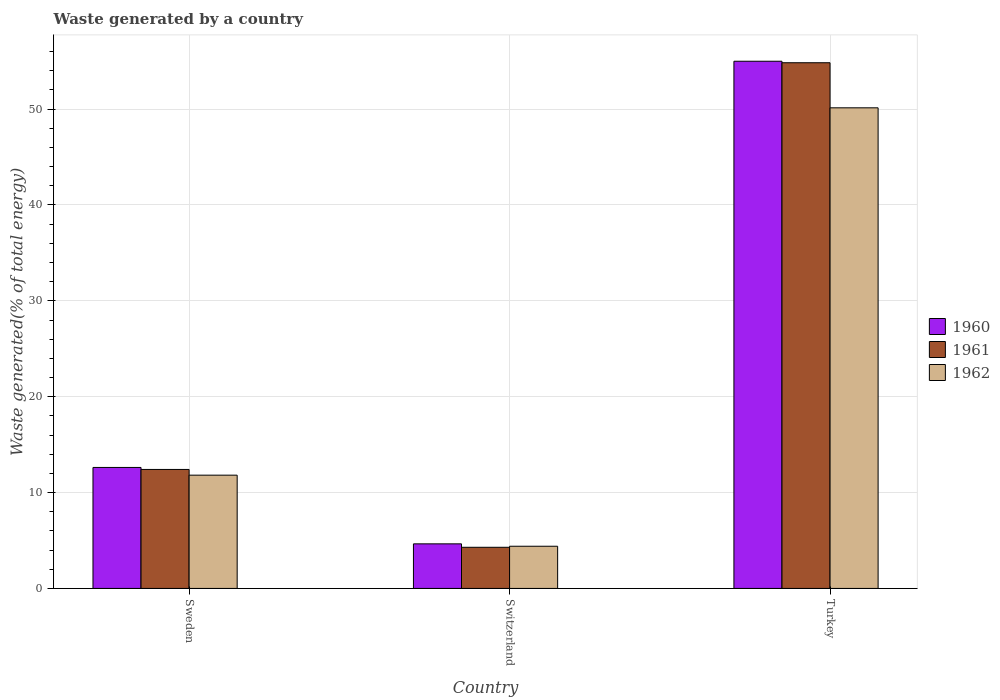How many different coloured bars are there?
Your response must be concise. 3. Are the number of bars per tick equal to the number of legend labels?
Provide a succinct answer. Yes. What is the label of the 2nd group of bars from the left?
Your response must be concise. Switzerland. What is the total waste generated in 1961 in Turkey?
Give a very brief answer. 54.84. Across all countries, what is the maximum total waste generated in 1961?
Give a very brief answer. 54.84. Across all countries, what is the minimum total waste generated in 1962?
Make the answer very short. 4.4. In which country was the total waste generated in 1960 maximum?
Keep it short and to the point. Turkey. In which country was the total waste generated in 1962 minimum?
Make the answer very short. Switzerland. What is the total total waste generated in 1961 in the graph?
Make the answer very short. 71.54. What is the difference between the total waste generated in 1962 in Sweden and that in Turkey?
Offer a very short reply. -38.32. What is the difference between the total waste generated in 1962 in Switzerland and the total waste generated in 1960 in Sweden?
Provide a succinct answer. -8.22. What is the average total waste generated in 1961 per country?
Your response must be concise. 23.85. What is the difference between the total waste generated of/in 1962 and total waste generated of/in 1960 in Sweden?
Offer a very short reply. -0.81. What is the ratio of the total waste generated in 1961 in Switzerland to that in Turkey?
Ensure brevity in your answer.  0.08. Is the total waste generated in 1960 in Sweden less than that in Turkey?
Your answer should be compact. Yes. What is the difference between the highest and the second highest total waste generated in 1962?
Your answer should be compact. 38.32. What is the difference between the highest and the lowest total waste generated in 1961?
Make the answer very short. 50.55. In how many countries, is the total waste generated in 1960 greater than the average total waste generated in 1960 taken over all countries?
Provide a succinct answer. 1. What does the 3rd bar from the left in Turkey represents?
Offer a terse response. 1962. Is it the case that in every country, the sum of the total waste generated in 1961 and total waste generated in 1962 is greater than the total waste generated in 1960?
Your answer should be compact. Yes. Where does the legend appear in the graph?
Offer a terse response. Center right. How many legend labels are there?
Make the answer very short. 3. How are the legend labels stacked?
Offer a very short reply. Vertical. What is the title of the graph?
Ensure brevity in your answer.  Waste generated by a country. Does "2007" appear as one of the legend labels in the graph?
Provide a succinct answer. No. What is the label or title of the X-axis?
Your answer should be very brief. Country. What is the label or title of the Y-axis?
Keep it short and to the point. Waste generated(% of total energy). What is the Waste generated(% of total energy) of 1960 in Sweden?
Offer a very short reply. 12.62. What is the Waste generated(% of total energy) in 1961 in Sweden?
Your answer should be very brief. 12.41. What is the Waste generated(% of total energy) in 1962 in Sweden?
Offer a very short reply. 11.82. What is the Waste generated(% of total energy) in 1960 in Switzerland?
Provide a short and direct response. 4.65. What is the Waste generated(% of total energy) in 1961 in Switzerland?
Give a very brief answer. 4.29. What is the Waste generated(% of total energy) in 1962 in Switzerland?
Offer a very short reply. 4.4. What is the Waste generated(% of total energy) in 1960 in Turkey?
Offer a terse response. 54.99. What is the Waste generated(% of total energy) in 1961 in Turkey?
Offer a terse response. 54.84. What is the Waste generated(% of total energy) of 1962 in Turkey?
Provide a succinct answer. 50.13. Across all countries, what is the maximum Waste generated(% of total energy) of 1960?
Make the answer very short. 54.99. Across all countries, what is the maximum Waste generated(% of total energy) in 1961?
Make the answer very short. 54.84. Across all countries, what is the maximum Waste generated(% of total energy) in 1962?
Give a very brief answer. 50.13. Across all countries, what is the minimum Waste generated(% of total energy) of 1960?
Keep it short and to the point. 4.65. Across all countries, what is the minimum Waste generated(% of total energy) of 1961?
Make the answer very short. 4.29. Across all countries, what is the minimum Waste generated(% of total energy) of 1962?
Make the answer very short. 4.4. What is the total Waste generated(% of total energy) of 1960 in the graph?
Offer a very short reply. 72.27. What is the total Waste generated(% of total energy) in 1961 in the graph?
Offer a very short reply. 71.54. What is the total Waste generated(% of total energy) in 1962 in the graph?
Provide a succinct answer. 66.35. What is the difference between the Waste generated(% of total energy) in 1960 in Sweden and that in Switzerland?
Offer a very short reply. 7.97. What is the difference between the Waste generated(% of total energy) in 1961 in Sweden and that in Switzerland?
Make the answer very short. 8.12. What is the difference between the Waste generated(% of total energy) of 1962 in Sweden and that in Switzerland?
Provide a succinct answer. 7.41. What is the difference between the Waste generated(% of total energy) in 1960 in Sweden and that in Turkey?
Your answer should be compact. -42.37. What is the difference between the Waste generated(% of total energy) in 1961 in Sweden and that in Turkey?
Make the answer very short. -42.43. What is the difference between the Waste generated(% of total energy) in 1962 in Sweden and that in Turkey?
Your answer should be very brief. -38.32. What is the difference between the Waste generated(% of total energy) in 1960 in Switzerland and that in Turkey?
Make the answer very short. -50.34. What is the difference between the Waste generated(% of total energy) of 1961 in Switzerland and that in Turkey?
Keep it short and to the point. -50.55. What is the difference between the Waste generated(% of total energy) of 1962 in Switzerland and that in Turkey?
Provide a succinct answer. -45.73. What is the difference between the Waste generated(% of total energy) of 1960 in Sweden and the Waste generated(% of total energy) of 1961 in Switzerland?
Keep it short and to the point. 8.33. What is the difference between the Waste generated(% of total energy) of 1960 in Sweden and the Waste generated(% of total energy) of 1962 in Switzerland?
Your answer should be compact. 8.22. What is the difference between the Waste generated(% of total energy) in 1961 in Sweden and the Waste generated(% of total energy) in 1962 in Switzerland?
Your answer should be compact. 8.01. What is the difference between the Waste generated(% of total energy) of 1960 in Sweden and the Waste generated(% of total energy) of 1961 in Turkey?
Your response must be concise. -42.22. What is the difference between the Waste generated(% of total energy) of 1960 in Sweden and the Waste generated(% of total energy) of 1962 in Turkey?
Your answer should be very brief. -37.51. What is the difference between the Waste generated(% of total energy) of 1961 in Sweden and the Waste generated(% of total energy) of 1962 in Turkey?
Your answer should be very brief. -37.72. What is the difference between the Waste generated(% of total energy) of 1960 in Switzerland and the Waste generated(% of total energy) of 1961 in Turkey?
Provide a short and direct response. -50.19. What is the difference between the Waste generated(% of total energy) of 1960 in Switzerland and the Waste generated(% of total energy) of 1962 in Turkey?
Keep it short and to the point. -45.48. What is the difference between the Waste generated(% of total energy) in 1961 in Switzerland and the Waste generated(% of total energy) in 1962 in Turkey?
Your answer should be very brief. -45.84. What is the average Waste generated(% of total energy) in 1960 per country?
Offer a very short reply. 24.09. What is the average Waste generated(% of total energy) of 1961 per country?
Your answer should be very brief. 23.85. What is the average Waste generated(% of total energy) in 1962 per country?
Ensure brevity in your answer.  22.12. What is the difference between the Waste generated(% of total energy) in 1960 and Waste generated(% of total energy) in 1961 in Sweden?
Provide a succinct answer. 0.21. What is the difference between the Waste generated(% of total energy) in 1960 and Waste generated(% of total energy) in 1962 in Sweden?
Provide a short and direct response. 0.81. What is the difference between the Waste generated(% of total energy) of 1961 and Waste generated(% of total energy) of 1962 in Sweden?
Ensure brevity in your answer.  0.6. What is the difference between the Waste generated(% of total energy) of 1960 and Waste generated(% of total energy) of 1961 in Switzerland?
Your response must be concise. 0.36. What is the difference between the Waste generated(% of total energy) in 1960 and Waste generated(% of total energy) in 1962 in Switzerland?
Provide a succinct answer. 0.25. What is the difference between the Waste generated(% of total energy) in 1961 and Waste generated(% of total energy) in 1962 in Switzerland?
Provide a succinct answer. -0.11. What is the difference between the Waste generated(% of total energy) of 1960 and Waste generated(% of total energy) of 1961 in Turkey?
Offer a very short reply. 0.16. What is the difference between the Waste generated(% of total energy) of 1960 and Waste generated(% of total energy) of 1962 in Turkey?
Give a very brief answer. 4.86. What is the difference between the Waste generated(% of total energy) of 1961 and Waste generated(% of total energy) of 1962 in Turkey?
Your answer should be very brief. 4.7. What is the ratio of the Waste generated(% of total energy) of 1960 in Sweden to that in Switzerland?
Ensure brevity in your answer.  2.71. What is the ratio of the Waste generated(% of total energy) in 1961 in Sweden to that in Switzerland?
Offer a terse response. 2.89. What is the ratio of the Waste generated(% of total energy) of 1962 in Sweden to that in Switzerland?
Give a very brief answer. 2.68. What is the ratio of the Waste generated(% of total energy) in 1960 in Sweden to that in Turkey?
Offer a terse response. 0.23. What is the ratio of the Waste generated(% of total energy) of 1961 in Sweden to that in Turkey?
Ensure brevity in your answer.  0.23. What is the ratio of the Waste generated(% of total energy) in 1962 in Sweden to that in Turkey?
Provide a succinct answer. 0.24. What is the ratio of the Waste generated(% of total energy) of 1960 in Switzerland to that in Turkey?
Ensure brevity in your answer.  0.08. What is the ratio of the Waste generated(% of total energy) of 1961 in Switzerland to that in Turkey?
Provide a short and direct response. 0.08. What is the ratio of the Waste generated(% of total energy) of 1962 in Switzerland to that in Turkey?
Keep it short and to the point. 0.09. What is the difference between the highest and the second highest Waste generated(% of total energy) of 1960?
Your answer should be compact. 42.37. What is the difference between the highest and the second highest Waste generated(% of total energy) in 1961?
Your response must be concise. 42.43. What is the difference between the highest and the second highest Waste generated(% of total energy) in 1962?
Your answer should be compact. 38.32. What is the difference between the highest and the lowest Waste generated(% of total energy) in 1960?
Provide a short and direct response. 50.34. What is the difference between the highest and the lowest Waste generated(% of total energy) in 1961?
Keep it short and to the point. 50.55. What is the difference between the highest and the lowest Waste generated(% of total energy) of 1962?
Keep it short and to the point. 45.73. 